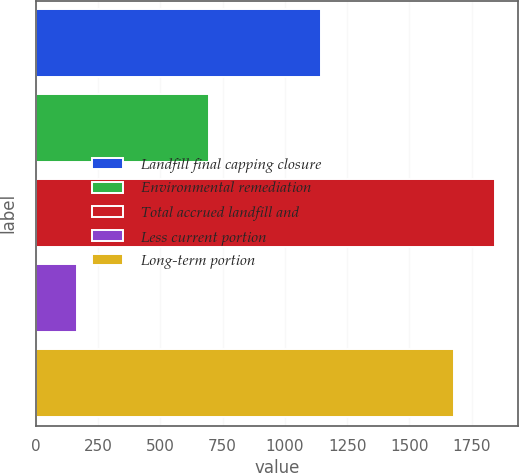Convert chart. <chart><loc_0><loc_0><loc_500><loc_500><bar_chart><fcel>Landfill final capping closure<fcel>Environmental remediation<fcel>Total accrued landfill and<fcel>Less current portion<fcel>Long-term portion<nl><fcel>1144.3<fcel>697.5<fcel>1845.25<fcel>164.3<fcel>1677.5<nl></chart> 